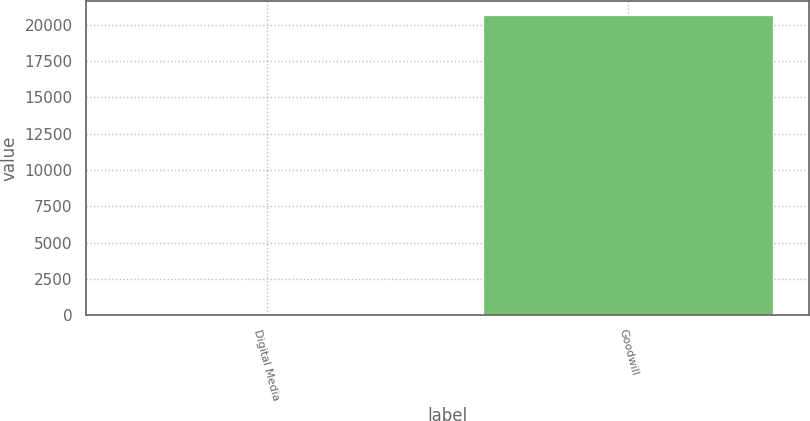Convert chart. <chart><loc_0><loc_0><loc_500><loc_500><bar_chart><fcel>Digital Media<fcel>Goodwill<nl><fcel>41<fcel>20628<nl></chart> 